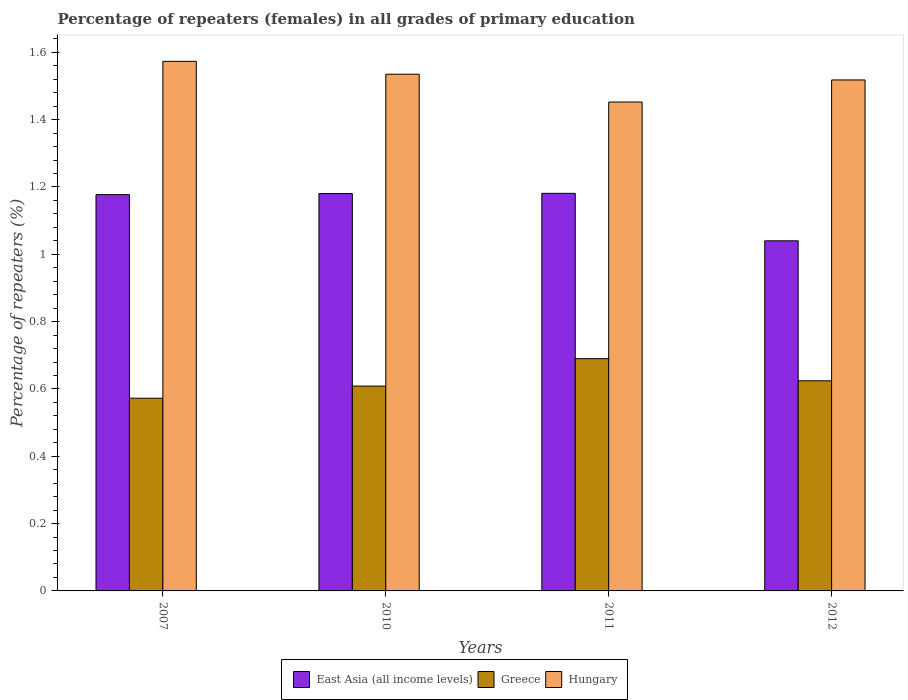How many groups of bars are there?
Offer a terse response. 4. Are the number of bars per tick equal to the number of legend labels?
Your answer should be compact. Yes. How many bars are there on the 3rd tick from the left?
Your answer should be compact. 3. How many bars are there on the 3rd tick from the right?
Make the answer very short. 3. What is the label of the 3rd group of bars from the left?
Your response must be concise. 2011. In how many cases, is the number of bars for a given year not equal to the number of legend labels?
Your answer should be very brief. 0. What is the percentage of repeaters (females) in Greece in 2012?
Offer a terse response. 0.62. Across all years, what is the maximum percentage of repeaters (females) in Hungary?
Offer a terse response. 1.57. Across all years, what is the minimum percentage of repeaters (females) in Hungary?
Keep it short and to the point. 1.45. In which year was the percentage of repeaters (females) in Greece maximum?
Ensure brevity in your answer.  2011. In which year was the percentage of repeaters (females) in East Asia (all income levels) minimum?
Provide a short and direct response. 2012. What is the total percentage of repeaters (females) in East Asia (all income levels) in the graph?
Provide a succinct answer. 4.58. What is the difference between the percentage of repeaters (females) in Hungary in 2010 and that in 2012?
Offer a very short reply. 0.02. What is the difference between the percentage of repeaters (females) in Hungary in 2010 and the percentage of repeaters (females) in East Asia (all income levels) in 2012?
Give a very brief answer. 0.49. What is the average percentage of repeaters (females) in East Asia (all income levels) per year?
Your response must be concise. 1.14. In the year 2007, what is the difference between the percentage of repeaters (females) in East Asia (all income levels) and percentage of repeaters (females) in Greece?
Your response must be concise. 0.6. What is the ratio of the percentage of repeaters (females) in Hungary in 2007 to that in 2012?
Keep it short and to the point. 1.04. Is the difference between the percentage of repeaters (females) in East Asia (all income levels) in 2011 and 2012 greater than the difference between the percentage of repeaters (females) in Greece in 2011 and 2012?
Your answer should be compact. Yes. What is the difference between the highest and the second highest percentage of repeaters (females) in East Asia (all income levels)?
Your answer should be compact. 0. What is the difference between the highest and the lowest percentage of repeaters (females) in Hungary?
Give a very brief answer. 0.12. Is the sum of the percentage of repeaters (females) in Greece in 2010 and 2011 greater than the maximum percentage of repeaters (females) in Hungary across all years?
Provide a succinct answer. No. What does the 1st bar from the right in 2012 represents?
Ensure brevity in your answer.  Hungary. How many years are there in the graph?
Make the answer very short. 4. Does the graph contain any zero values?
Your answer should be very brief. No. Where does the legend appear in the graph?
Give a very brief answer. Bottom center. How many legend labels are there?
Give a very brief answer. 3. How are the legend labels stacked?
Your answer should be compact. Horizontal. What is the title of the graph?
Ensure brevity in your answer.  Percentage of repeaters (females) in all grades of primary education. What is the label or title of the X-axis?
Make the answer very short. Years. What is the label or title of the Y-axis?
Provide a short and direct response. Percentage of repeaters (%). What is the Percentage of repeaters (%) in East Asia (all income levels) in 2007?
Offer a terse response. 1.18. What is the Percentage of repeaters (%) in Greece in 2007?
Keep it short and to the point. 0.57. What is the Percentage of repeaters (%) of Hungary in 2007?
Make the answer very short. 1.57. What is the Percentage of repeaters (%) in East Asia (all income levels) in 2010?
Your answer should be compact. 1.18. What is the Percentage of repeaters (%) of Greece in 2010?
Your response must be concise. 0.61. What is the Percentage of repeaters (%) of Hungary in 2010?
Your answer should be very brief. 1.53. What is the Percentage of repeaters (%) in East Asia (all income levels) in 2011?
Offer a very short reply. 1.18. What is the Percentage of repeaters (%) of Greece in 2011?
Ensure brevity in your answer.  0.69. What is the Percentage of repeaters (%) in Hungary in 2011?
Your answer should be compact. 1.45. What is the Percentage of repeaters (%) of East Asia (all income levels) in 2012?
Give a very brief answer. 1.04. What is the Percentage of repeaters (%) of Greece in 2012?
Provide a succinct answer. 0.62. What is the Percentage of repeaters (%) in Hungary in 2012?
Keep it short and to the point. 1.52. Across all years, what is the maximum Percentage of repeaters (%) of East Asia (all income levels)?
Offer a terse response. 1.18. Across all years, what is the maximum Percentage of repeaters (%) of Greece?
Keep it short and to the point. 0.69. Across all years, what is the maximum Percentage of repeaters (%) of Hungary?
Keep it short and to the point. 1.57. Across all years, what is the minimum Percentage of repeaters (%) of East Asia (all income levels)?
Your answer should be very brief. 1.04. Across all years, what is the minimum Percentage of repeaters (%) in Greece?
Your answer should be compact. 0.57. Across all years, what is the minimum Percentage of repeaters (%) of Hungary?
Your answer should be very brief. 1.45. What is the total Percentage of repeaters (%) in East Asia (all income levels) in the graph?
Give a very brief answer. 4.58. What is the total Percentage of repeaters (%) of Greece in the graph?
Offer a terse response. 2.5. What is the total Percentage of repeaters (%) of Hungary in the graph?
Make the answer very short. 6.08. What is the difference between the Percentage of repeaters (%) of East Asia (all income levels) in 2007 and that in 2010?
Your answer should be compact. -0. What is the difference between the Percentage of repeaters (%) in Greece in 2007 and that in 2010?
Your response must be concise. -0.04. What is the difference between the Percentage of repeaters (%) in Hungary in 2007 and that in 2010?
Make the answer very short. 0.04. What is the difference between the Percentage of repeaters (%) of East Asia (all income levels) in 2007 and that in 2011?
Offer a very short reply. -0. What is the difference between the Percentage of repeaters (%) of Greece in 2007 and that in 2011?
Offer a very short reply. -0.12. What is the difference between the Percentage of repeaters (%) of Hungary in 2007 and that in 2011?
Make the answer very short. 0.12. What is the difference between the Percentage of repeaters (%) in East Asia (all income levels) in 2007 and that in 2012?
Ensure brevity in your answer.  0.14. What is the difference between the Percentage of repeaters (%) in Greece in 2007 and that in 2012?
Keep it short and to the point. -0.05. What is the difference between the Percentage of repeaters (%) of Hungary in 2007 and that in 2012?
Offer a terse response. 0.06. What is the difference between the Percentage of repeaters (%) of East Asia (all income levels) in 2010 and that in 2011?
Keep it short and to the point. -0. What is the difference between the Percentage of repeaters (%) of Greece in 2010 and that in 2011?
Provide a succinct answer. -0.08. What is the difference between the Percentage of repeaters (%) of Hungary in 2010 and that in 2011?
Keep it short and to the point. 0.08. What is the difference between the Percentage of repeaters (%) of East Asia (all income levels) in 2010 and that in 2012?
Make the answer very short. 0.14. What is the difference between the Percentage of repeaters (%) in Greece in 2010 and that in 2012?
Offer a terse response. -0.02. What is the difference between the Percentage of repeaters (%) in Hungary in 2010 and that in 2012?
Your response must be concise. 0.02. What is the difference between the Percentage of repeaters (%) in East Asia (all income levels) in 2011 and that in 2012?
Your response must be concise. 0.14. What is the difference between the Percentage of repeaters (%) of Greece in 2011 and that in 2012?
Make the answer very short. 0.07. What is the difference between the Percentage of repeaters (%) of Hungary in 2011 and that in 2012?
Keep it short and to the point. -0.07. What is the difference between the Percentage of repeaters (%) in East Asia (all income levels) in 2007 and the Percentage of repeaters (%) in Greece in 2010?
Your answer should be compact. 0.57. What is the difference between the Percentage of repeaters (%) of East Asia (all income levels) in 2007 and the Percentage of repeaters (%) of Hungary in 2010?
Ensure brevity in your answer.  -0.36. What is the difference between the Percentage of repeaters (%) in Greece in 2007 and the Percentage of repeaters (%) in Hungary in 2010?
Your response must be concise. -0.96. What is the difference between the Percentage of repeaters (%) in East Asia (all income levels) in 2007 and the Percentage of repeaters (%) in Greece in 2011?
Your answer should be very brief. 0.49. What is the difference between the Percentage of repeaters (%) of East Asia (all income levels) in 2007 and the Percentage of repeaters (%) of Hungary in 2011?
Provide a succinct answer. -0.28. What is the difference between the Percentage of repeaters (%) in Greece in 2007 and the Percentage of repeaters (%) in Hungary in 2011?
Make the answer very short. -0.88. What is the difference between the Percentage of repeaters (%) of East Asia (all income levels) in 2007 and the Percentage of repeaters (%) of Greece in 2012?
Make the answer very short. 0.55. What is the difference between the Percentage of repeaters (%) in East Asia (all income levels) in 2007 and the Percentage of repeaters (%) in Hungary in 2012?
Your answer should be very brief. -0.34. What is the difference between the Percentage of repeaters (%) of Greece in 2007 and the Percentage of repeaters (%) of Hungary in 2012?
Your answer should be compact. -0.95. What is the difference between the Percentage of repeaters (%) in East Asia (all income levels) in 2010 and the Percentage of repeaters (%) in Greece in 2011?
Provide a succinct answer. 0.49. What is the difference between the Percentage of repeaters (%) of East Asia (all income levels) in 2010 and the Percentage of repeaters (%) of Hungary in 2011?
Your answer should be very brief. -0.27. What is the difference between the Percentage of repeaters (%) of Greece in 2010 and the Percentage of repeaters (%) of Hungary in 2011?
Ensure brevity in your answer.  -0.84. What is the difference between the Percentage of repeaters (%) in East Asia (all income levels) in 2010 and the Percentage of repeaters (%) in Greece in 2012?
Keep it short and to the point. 0.56. What is the difference between the Percentage of repeaters (%) of East Asia (all income levels) in 2010 and the Percentage of repeaters (%) of Hungary in 2012?
Give a very brief answer. -0.34. What is the difference between the Percentage of repeaters (%) in Greece in 2010 and the Percentage of repeaters (%) in Hungary in 2012?
Give a very brief answer. -0.91. What is the difference between the Percentage of repeaters (%) of East Asia (all income levels) in 2011 and the Percentage of repeaters (%) of Greece in 2012?
Your answer should be very brief. 0.56. What is the difference between the Percentage of repeaters (%) in East Asia (all income levels) in 2011 and the Percentage of repeaters (%) in Hungary in 2012?
Keep it short and to the point. -0.34. What is the difference between the Percentage of repeaters (%) in Greece in 2011 and the Percentage of repeaters (%) in Hungary in 2012?
Provide a short and direct response. -0.83. What is the average Percentage of repeaters (%) in East Asia (all income levels) per year?
Your answer should be very brief. 1.14. What is the average Percentage of repeaters (%) of Greece per year?
Ensure brevity in your answer.  0.62. What is the average Percentage of repeaters (%) of Hungary per year?
Give a very brief answer. 1.52. In the year 2007, what is the difference between the Percentage of repeaters (%) in East Asia (all income levels) and Percentage of repeaters (%) in Greece?
Provide a short and direct response. 0.6. In the year 2007, what is the difference between the Percentage of repeaters (%) of East Asia (all income levels) and Percentage of repeaters (%) of Hungary?
Your answer should be compact. -0.4. In the year 2007, what is the difference between the Percentage of repeaters (%) of Greece and Percentage of repeaters (%) of Hungary?
Offer a very short reply. -1. In the year 2010, what is the difference between the Percentage of repeaters (%) in East Asia (all income levels) and Percentage of repeaters (%) in Greece?
Provide a succinct answer. 0.57. In the year 2010, what is the difference between the Percentage of repeaters (%) of East Asia (all income levels) and Percentage of repeaters (%) of Hungary?
Give a very brief answer. -0.35. In the year 2010, what is the difference between the Percentage of repeaters (%) in Greece and Percentage of repeaters (%) in Hungary?
Give a very brief answer. -0.93. In the year 2011, what is the difference between the Percentage of repeaters (%) of East Asia (all income levels) and Percentage of repeaters (%) of Greece?
Your answer should be very brief. 0.49. In the year 2011, what is the difference between the Percentage of repeaters (%) of East Asia (all income levels) and Percentage of repeaters (%) of Hungary?
Make the answer very short. -0.27. In the year 2011, what is the difference between the Percentage of repeaters (%) in Greece and Percentage of repeaters (%) in Hungary?
Ensure brevity in your answer.  -0.76. In the year 2012, what is the difference between the Percentage of repeaters (%) in East Asia (all income levels) and Percentage of repeaters (%) in Greece?
Provide a short and direct response. 0.42. In the year 2012, what is the difference between the Percentage of repeaters (%) of East Asia (all income levels) and Percentage of repeaters (%) of Hungary?
Offer a terse response. -0.48. In the year 2012, what is the difference between the Percentage of repeaters (%) in Greece and Percentage of repeaters (%) in Hungary?
Offer a terse response. -0.89. What is the ratio of the Percentage of repeaters (%) of Greece in 2007 to that in 2010?
Provide a succinct answer. 0.94. What is the ratio of the Percentage of repeaters (%) in Hungary in 2007 to that in 2010?
Give a very brief answer. 1.02. What is the ratio of the Percentage of repeaters (%) in East Asia (all income levels) in 2007 to that in 2011?
Ensure brevity in your answer.  1. What is the ratio of the Percentage of repeaters (%) in Greece in 2007 to that in 2011?
Give a very brief answer. 0.83. What is the ratio of the Percentage of repeaters (%) in Hungary in 2007 to that in 2011?
Provide a short and direct response. 1.08. What is the ratio of the Percentage of repeaters (%) in East Asia (all income levels) in 2007 to that in 2012?
Keep it short and to the point. 1.13. What is the ratio of the Percentage of repeaters (%) in Greece in 2007 to that in 2012?
Ensure brevity in your answer.  0.92. What is the ratio of the Percentage of repeaters (%) in Hungary in 2007 to that in 2012?
Provide a short and direct response. 1.04. What is the ratio of the Percentage of repeaters (%) of Greece in 2010 to that in 2011?
Ensure brevity in your answer.  0.88. What is the ratio of the Percentage of repeaters (%) of Hungary in 2010 to that in 2011?
Provide a succinct answer. 1.06. What is the ratio of the Percentage of repeaters (%) of East Asia (all income levels) in 2010 to that in 2012?
Ensure brevity in your answer.  1.14. What is the ratio of the Percentage of repeaters (%) of Greece in 2010 to that in 2012?
Your answer should be compact. 0.97. What is the ratio of the Percentage of repeaters (%) of Hungary in 2010 to that in 2012?
Provide a succinct answer. 1.01. What is the ratio of the Percentage of repeaters (%) of East Asia (all income levels) in 2011 to that in 2012?
Offer a very short reply. 1.14. What is the ratio of the Percentage of repeaters (%) in Greece in 2011 to that in 2012?
Your answer should be very brief. 1.11. What is the ratio of the Percentage of repeaters (%) of Hungary in 2011 to that in 2012?
Ensure brevity in your answer.  0.96. What is the difference between the highest and the second highest Percentage of repeaters (%) of East Asia (all income levels)?
Provide a short and direct response. 0. What is the difference between the highest and the second highest Percentage of repeaters (%) of Greece?
Ensure brevity in your answer.  0.07. What is the difference between the highest and the second highest Percentage of repeaters (%) in Hungary?
Offer a terse response. 0.04. What is the difference between the highest and the lowest Percentage of repeaters (%) of East Asia (all income levels)?
Your response must be concise. 0.14. What is the difference between the highest and the lowest Percentage of repeaters (%) of Greece?
Provide a succinct answer. 0.12. What is the difference between the highest and the lowest Percentage of repeaters (%) in Hungary?
Make the answer very short. 0.12. 